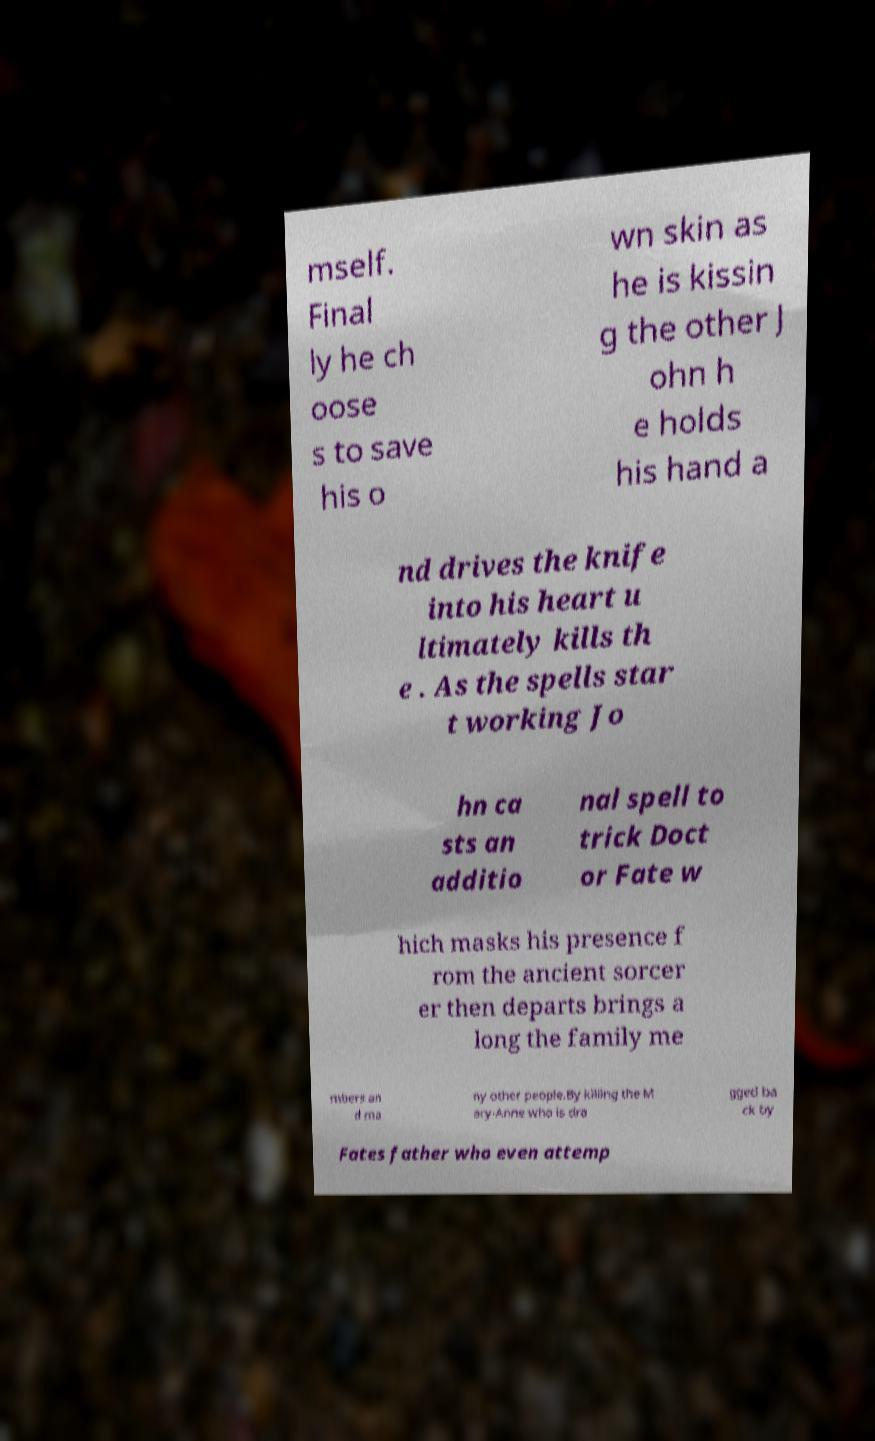Could you extract and type out the text from this image? mself. Final ly he ch oose s to save his o wn skin as he is kissin g the other J ohn h e holds his hand a nd drives the knife into his heart u ltimately kills th e . As the spells star t working Jo hn ca sts an additio nal spell to trick Doct or Fate w hich masks his presence f rom the ancient sorcer er then departs brings a long the family me mbers an d ma ny other people.By killing the M ary-Anne who is dra gged ba ck by Fates father who even attemp 